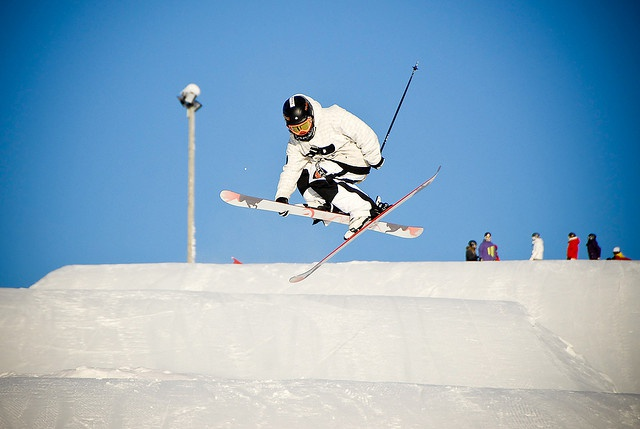Describe the objects in this image and their specific colors. I can see people in darkblue, ivory, black, darkgray, and gray tones, skis in darkblue, ivory, lightblue, and darkgray tones, skis in darkblue, lightgray, darkgray, and lightpink tones, people in darkblue, purple, tan, and khaki tones, and people in darkblue, brown, lightgray, and gray tones in this image. 